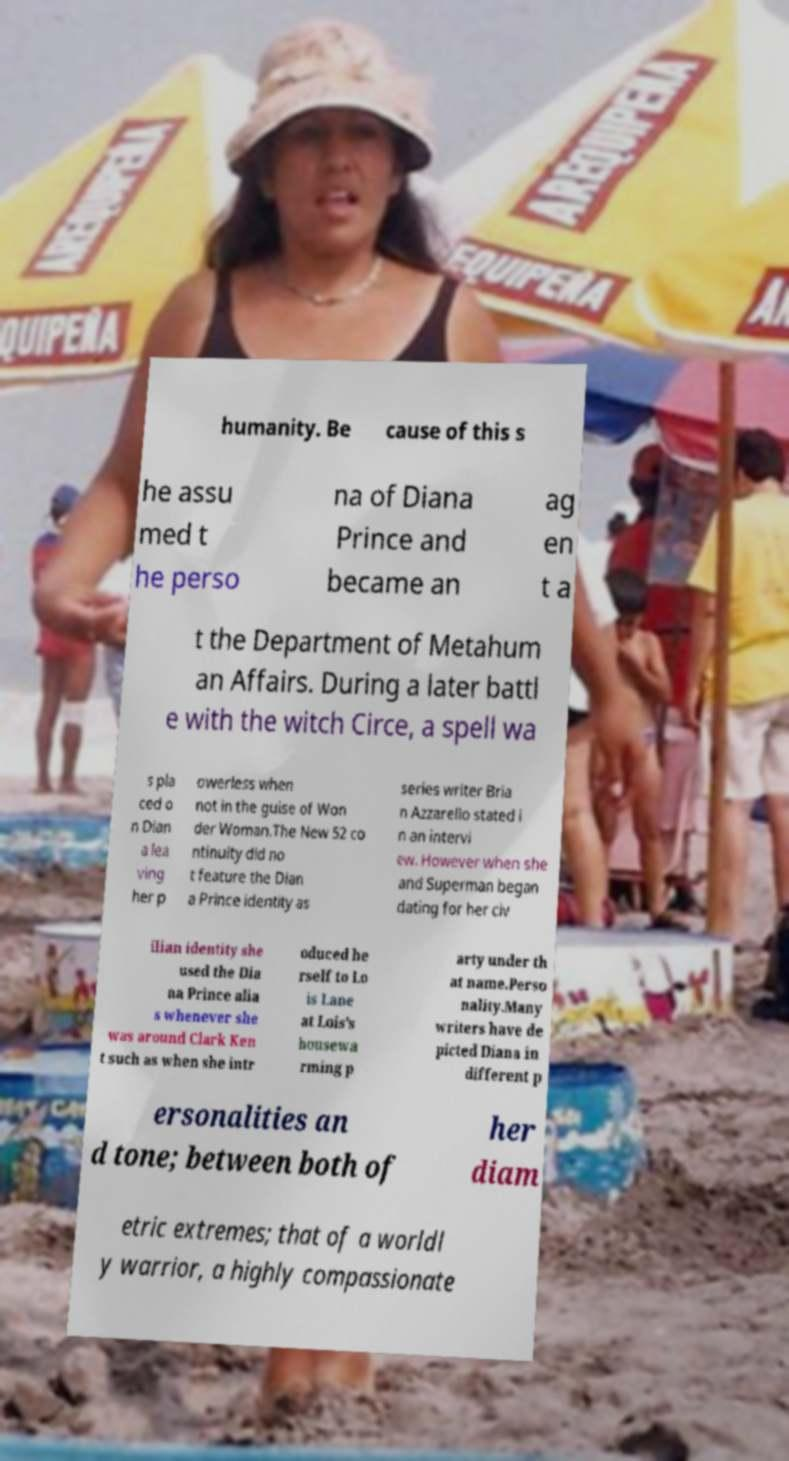There's text embedded in this image that I need extracted. Can you transcribe it verbatim? humanity. Be cause of this s he assu med t he perso na of Diana Prince and became an ag en t a t the Department of Metahum an Affairs. During a later battl e with the witch Circe, a spell wa s pla ced o n Dian a lea ving her p owerless when not in the guise of Won der Woman.The New 52 co ntinuity did no t feature the Dian a Prince identity as series writer Bria n Azzarello stated i n an intervi ew. However when she and Superman began dating for her civ ilian identity she used the Dia na Prince alia s whenever she was around Clark Ken t such as when she intr oduced he rself to Lo is Lane at Lois's housewa rming p arty under th at name.Perso nality.Many writers have de picted Diana in different p ersonalities an d tone; between both of her diam etric extremes; that of a worldl y warrior, a highly compassionate 